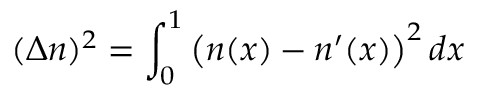<formula> <loc_0><loc_0><loc_500><loc_500>( \Delta n ) ^ { 2 } = \int _ { 0 } ^ { 1 } \left ( n ( x ) - n ^ { \prime } ( x ) \right ) ^ { 2 } d x</formula> 